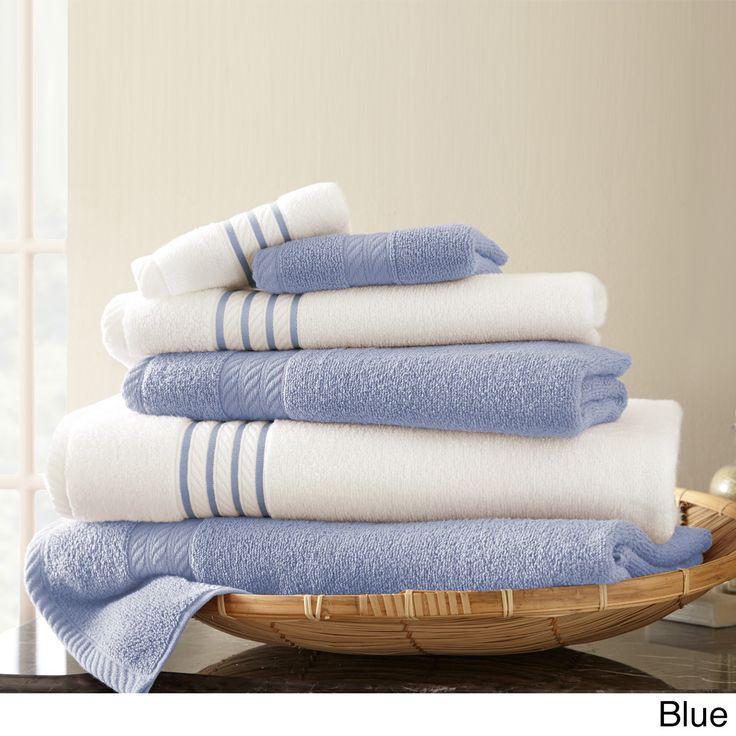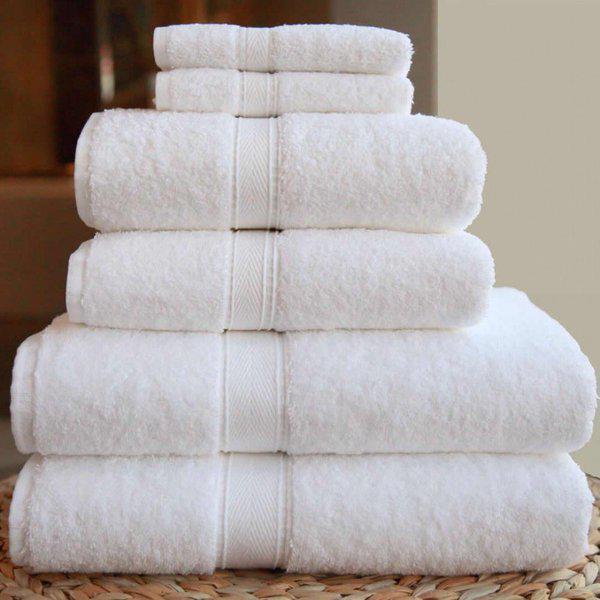The first image is the image on the left, the second image is the image on the right. Evaluate the accuracy of this statement regarding the images: "A towel pile includes white towels with contrast stripe trim.". Is it true? Answer yes or no. Yes. 